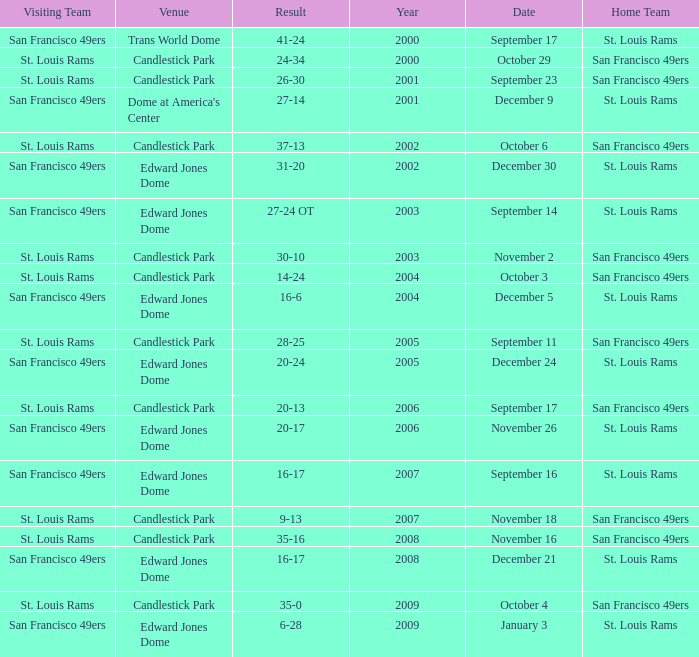What was the Venue on November 26? Edward Jones Dome. 